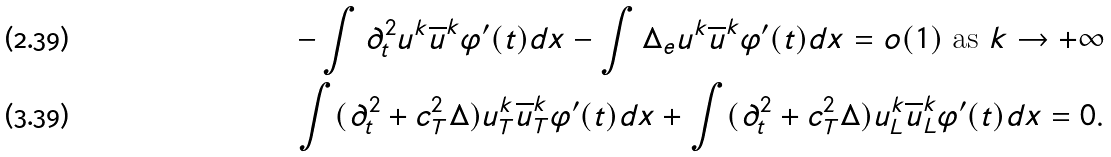Convert formula to latex. <formula><loc_0><loc_0><loc_500><loc_500>- \int \partial _ { t } ^ { 2 } u ^ { k } \overline { u } ^ { k } \varphi ^ { \prime } ( t ) d x - \int \Delta _ { e } u ^ { k } \overline { u } ^ { k } \varphi ^ { \prime } ( t ) d x = o ( 1 ) \text { as } k \rightarrow + \infty \\ \int ( \partial _ { t } ^ { 2 } + c _ { T } ^ { 2 } \Delta ) u _ { T } ^ { k } \overline { u } ^ { k } _ { T } \varphi ^ { \prime } ( t ) d x + \int ( \partial _ { t } ^ { 2 } + c _ { T } ^ { 2 } \Delta ) u _ { L } ^ { k } \overline { u } ^ { k } _ { L } \varphi ^ { \prime } ( t ) d x = 0 .</formula> 